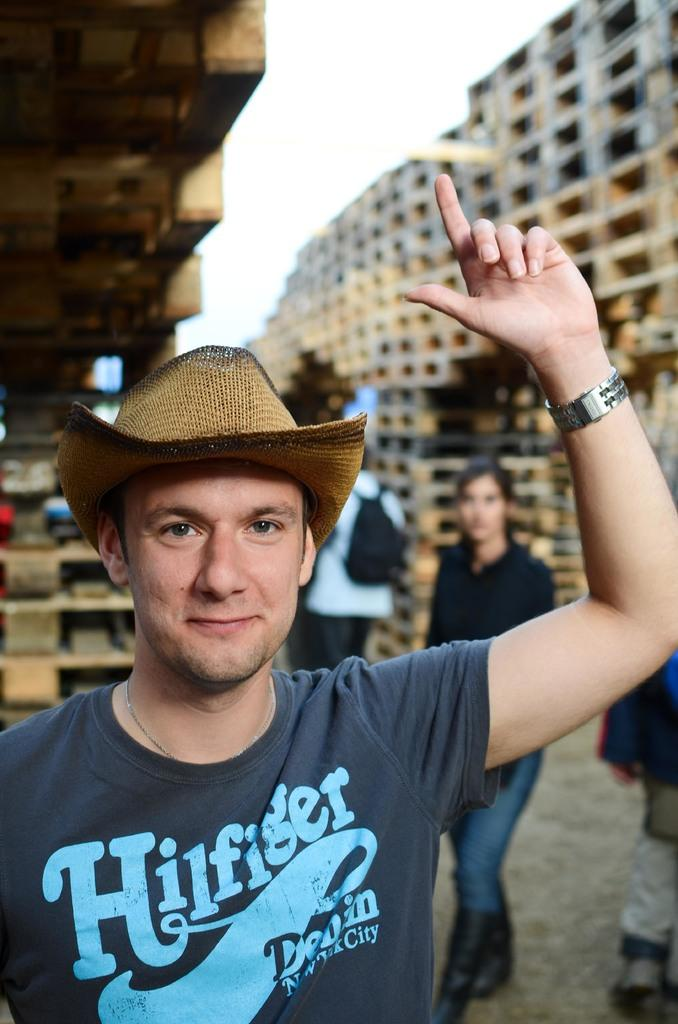What is the main subject of the image? There is a man in the image. What is the man wearing on his head? The man is wearing a cap. What accessory is the man wearing on his wrist? The man is wearing a watch. What expression does the man have in the image? The man is smiling. What can be seen in the background of the image? There are people and objects in the background of the image, as well as the sky. What type of bike is the man riding in the image? There is no bike present in the image; the man is not riding a bike. What time is it according to the hour hand on the man's watch? The image does not provide enough detail to determine the exact time on the man's watch. --- Facts: 1. There is a car in the image. 2. The car is red. 3. The car has four wheels. 4. There are people in the car. 5. The car has a license plate. 6. The license plate has numbers and letters. Absurd Topics: parrot, ocean, mountain Conversation: What is the main subject of the image? There is a car in the image. What color is the car? The car is red. How many wheels does the car have? The car has four wheels. Who is inside the car? There are people in the car. What can be found on the car's exterior? The car has a license plate. Reasoning: Let's think step by step in order to produce the conversation. We start by identifying the main subject of the image, which is the car. Then, we describe specific details about the car, such as its color, number of wheels, and the presence of people inside. Next, we acknowledge the presence of a license plate on the car's exterior. Each question is designed to elicit a specific detail about the image that is known from the provided facts. Absurd Question/Answer: Can you see a parrot sitting on the car's roof in the image? No, there is no parrot present in the image. Is the car parked near the ocean in the image? The image does not provide any information about the car's location in relation to the ocean. 